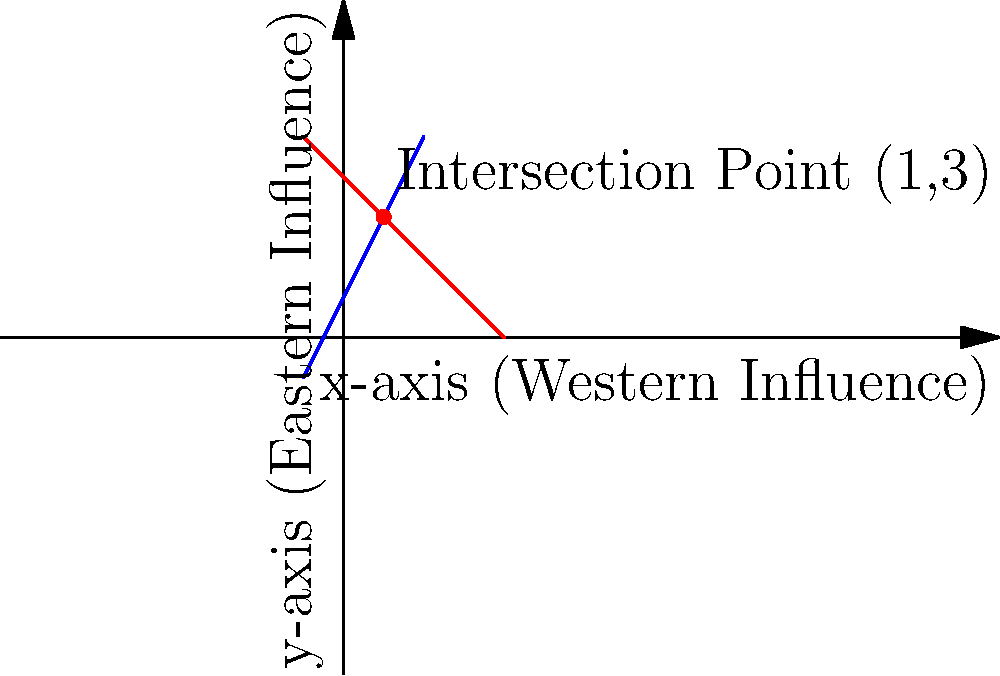In the context of geopolitical interests, two major powers, Russia and the USA, have conflicting strategic objectives represented by linear equations. Russia's interests are represented by the equation $y = 2x + 1$, while the USA's interests are represented by $y = -x + 4$. At what point do these interests intersect, potentially creating a diplomatic flashpoint? To find the intersection point of the two lines representing Russia's and USA's interests, we need to solve the system of equations:

1) Russia's interests: $y = 2x + 1$
2) USA's interests: $y = -x + 4$

At the intersection point, the y-values are equal, so we can set the equations equal to each other:

$2x + 1 = -x + 4$

Now, let's solve for x:

$2x + 1 = -x + 4$
$3x = 3$
$x = 1$

To find the y-coordinate of the intersection point, we can substitute $x = 1$ into either equation. Let's use Russia's equation:

$y = 2(1) + 1 = 3$

Therefore, the intersection point is $(1, 3)$.

This point represents where the geopolitical interests of Russia and the USA converge, which could be interpreted as a potential area of conflict or negotiation in the diplomatic arena.
Answer: $(1, 3)$ 